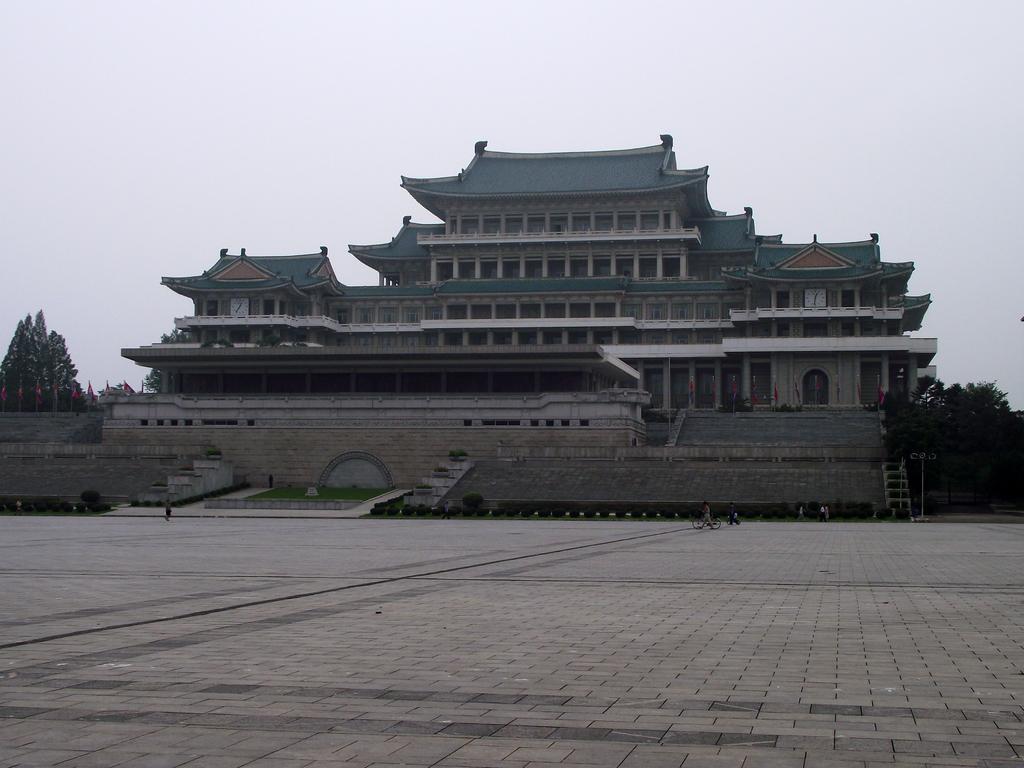How would you summarize this image in a sentence or two? There is empty land in the foreground area of the image, there are people, building structure, trees and the sky in the background. 